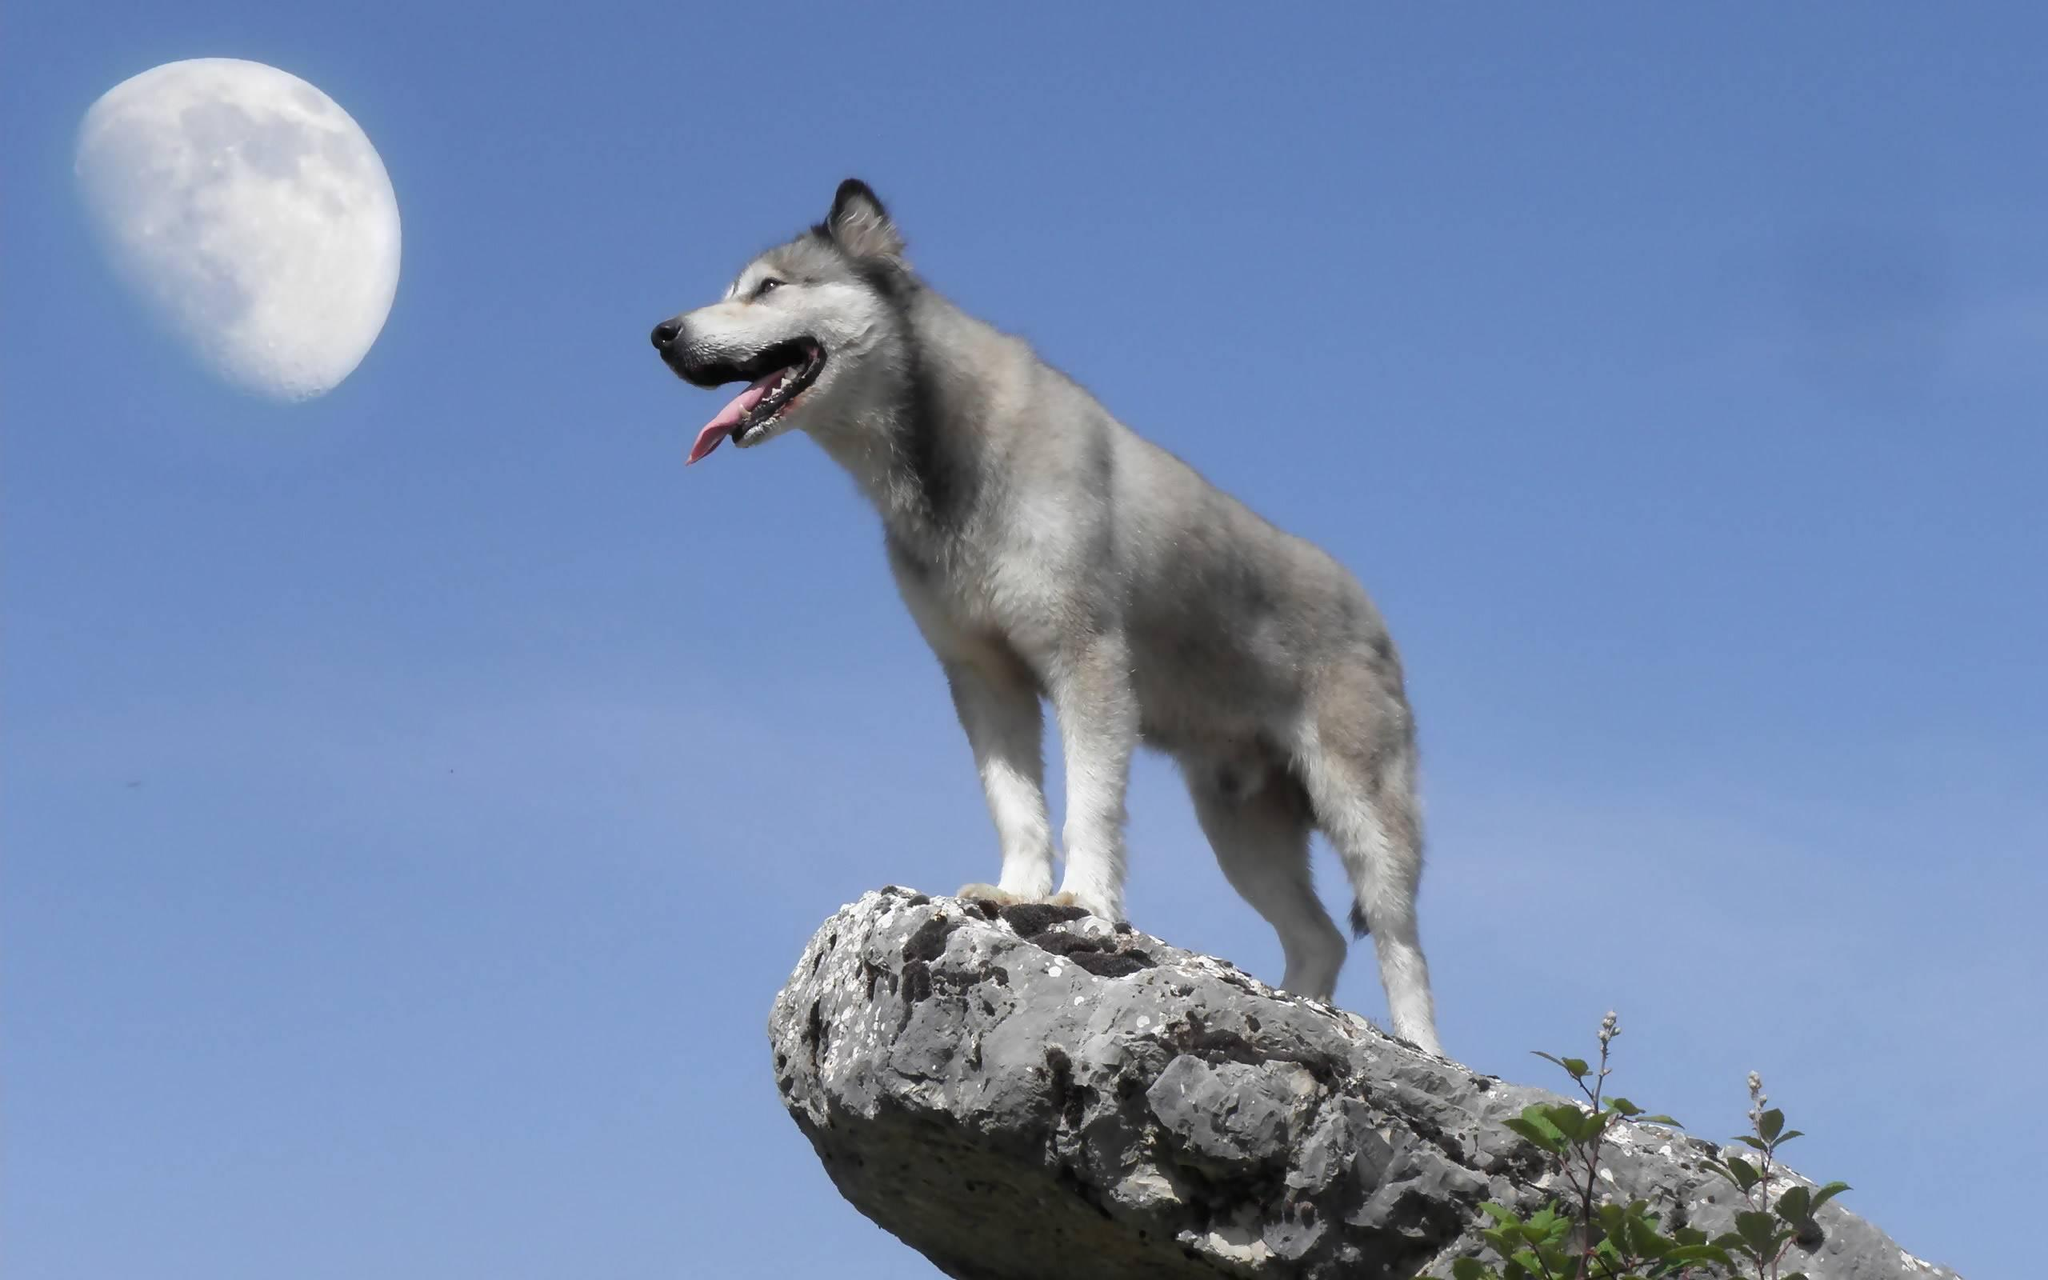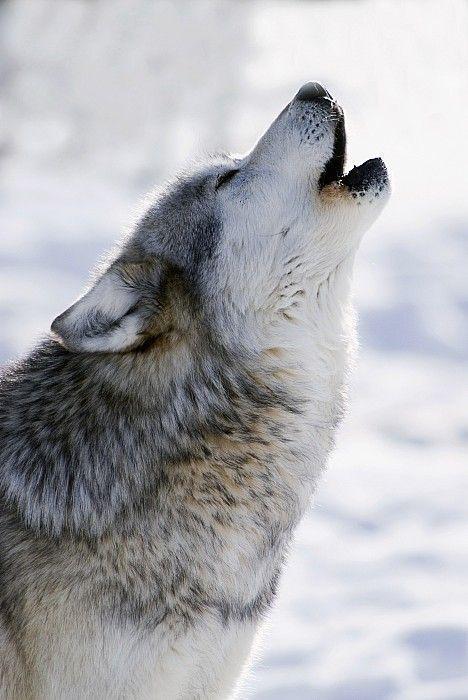The first image is the image on the left, the second image is the image on the right. Given the left and right images, does the statement "There are three wolves" hold true? Answer yes or no. No. 